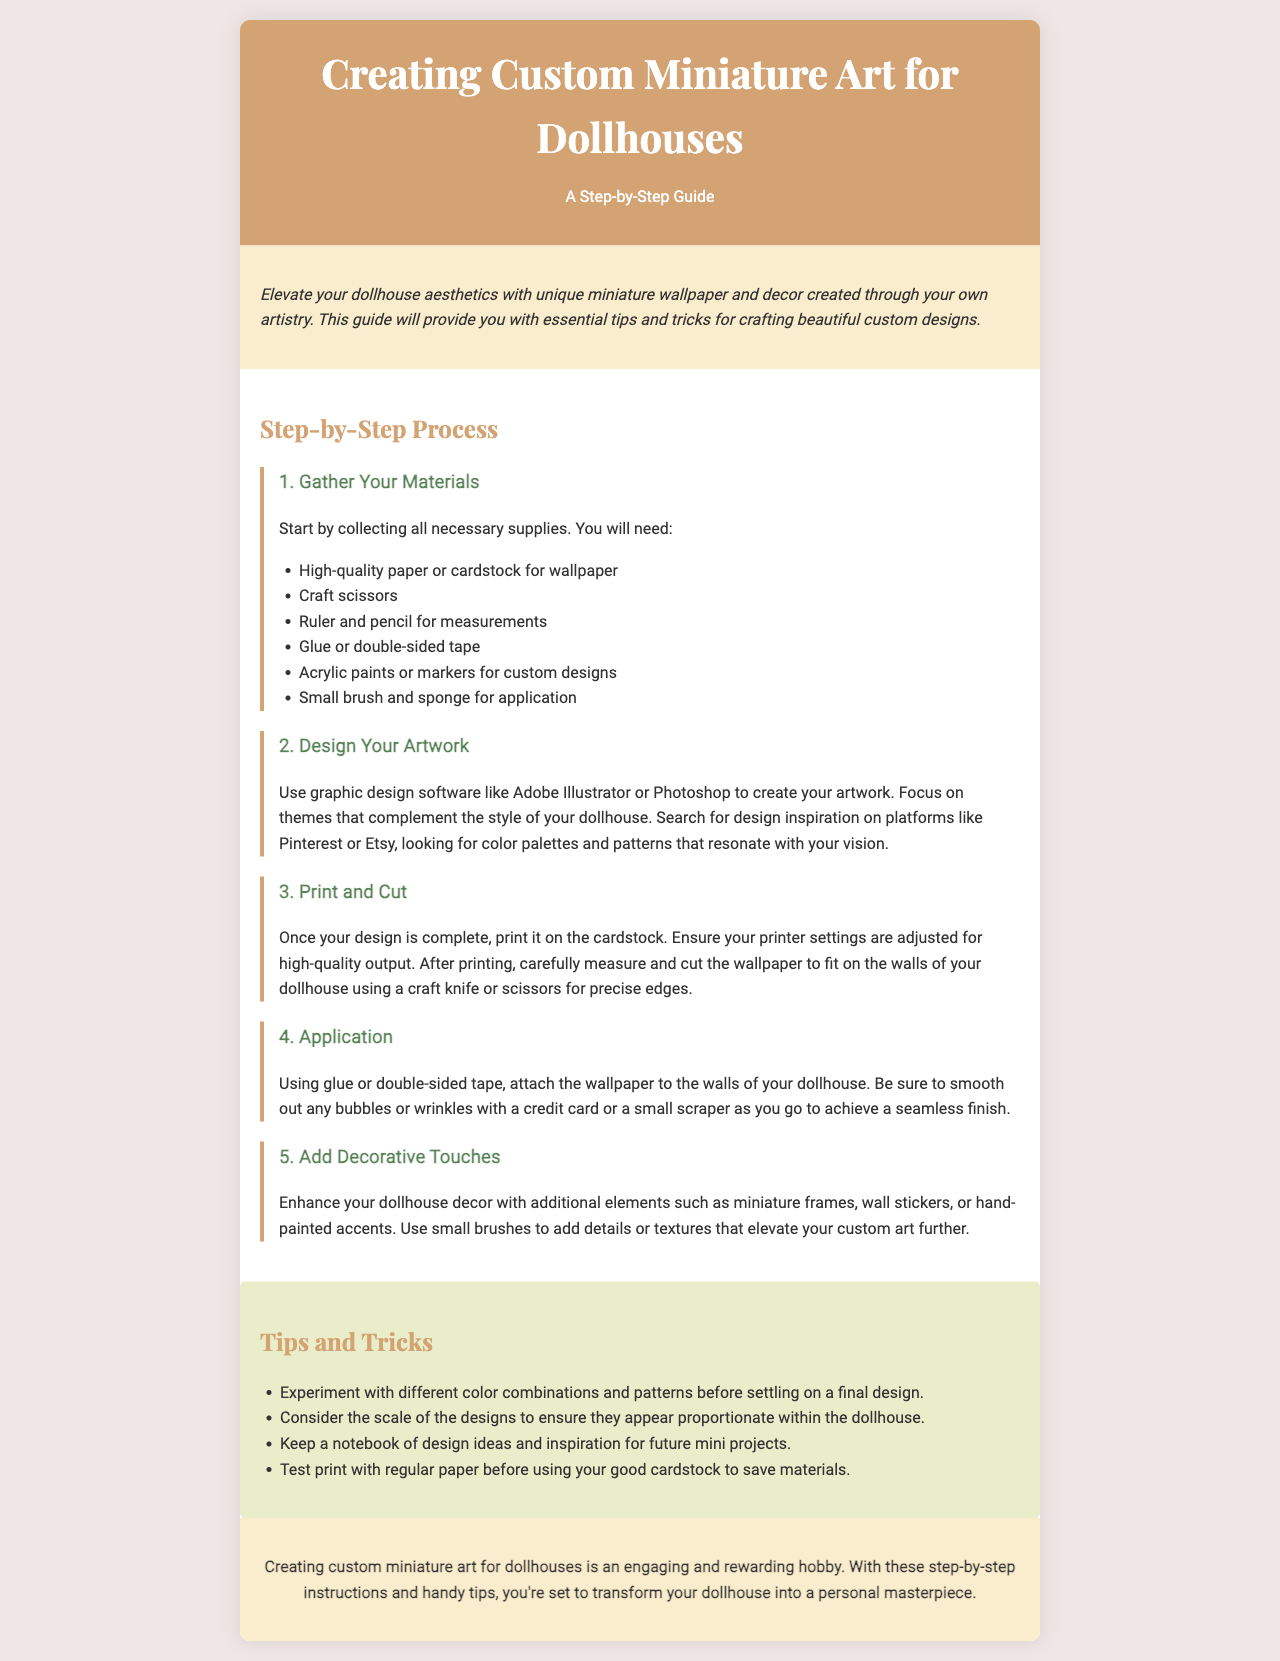What is the main topic of the brochure? The main topic is about creating custom miniature art for dollhouses.
Answer: Creating Custom Miniature Art for Dollhouses What is the first step in the process? The first step in the step-by-step process outlined in the brochure is gathering materials.
Answer: Gather Your Materials How many steps are included in the process? There are five steps included in the step-by-step process in the document.
Answer: Five What type of glue is suggested for application? The document suggests using glue or double-sided tape for applying the wallpaper.
Answer: Glue or double-sided tape Which graphic design software is recommended? The brochure recommends using Adobe Illustrator or Photoshop for designing artwork.
Answer: Adobe Illustrator or Photoshop What should you do before using cardstock for printing? The document advises testing print with regular paper before using good cardstock to save materials.
Answer: Test print with regular paper What is an example of a decorative touch for the dollhouse? The document suggests adding miniature frames, wall stickers, or hand-painted accents as decorative touches.
Answer: Miniature frames, wall stickers, or hand-painted accents What is an important consideration mentioned for design scale? The document states to consider the scale of the designs to ensure they appear proportionate within the dollhouse.
Answer: Scale of the designs What section of the brochure provides additional tips? The section titled "Tips and Tricks" provides additional tips for creating custom miniature art.
Answer: Tips and Tricks 